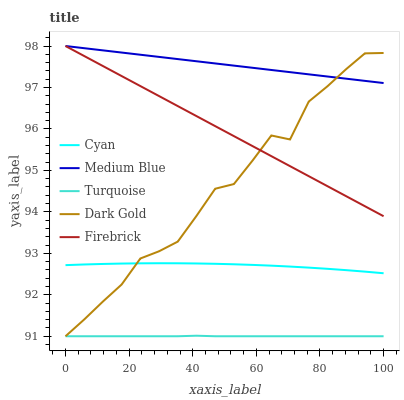Does Turquoise have the minimum area under the curve?
Answer yes or no. Yes. Does Medium Blue have the maximum area under the curve?
Answer yes or no. Yes. Does Medium Blue have the minimum area under the curve?
Answer yes or no. No. Does Turquoise have the maximum area under the curve?
Answer yes or no. No. Is Medium Blue the smoothest?
Answer yes or no. Yes. Is Dark Gold the roughest?
Answer yes or no. Yes. Is Turquoise the smoothest?
Answer yes or no. No. Is Turquoise the roughest?
Answer yes or no. No. Does Turquoise have the lowest value?
Answer yes or no. Yes. Does Medium Blue have the lowest value?
Answer yes or no. No. Does Firebrick have the highest value?
Answer yes or no. Yes. Does Turquoise have the highest value?
Answer yes or no. No. Is Turquoise less than Cyan?
Answer yes or no. Yes. Is Cyan greater than Turquoise?
Answer yes or no. Yes. Does Dark Gold intersect Turquoise?
Answer yes or no. Yes. Is Dark Gold less than Turquoise?
Answer yes or no. No. Is Dark Gold greater than Turquoise?
Answer yes or no. No. Does Turquoise intersect Cyan?
Answer yes or no. No. 